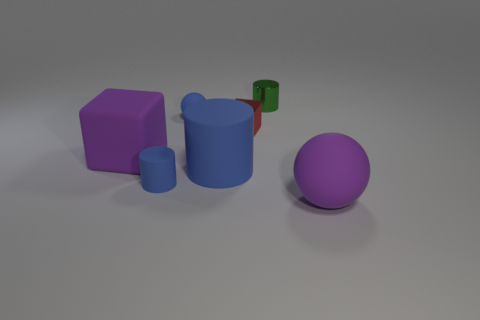Add 1 large rubber spheres. How many objects exist? 8 Subtract all cylinders. How many objects are left? 4 Subtract 0 red balls. How many objects are left? 7 Subtract all small blue rubber cylinders. Subtract all blue cylinders. How many objects are left? 4 Add 1 large purple spheres. How many large purple spheres are left? 2 Add 4 large cyan spheres. How many large cyan spheres exist? 4 